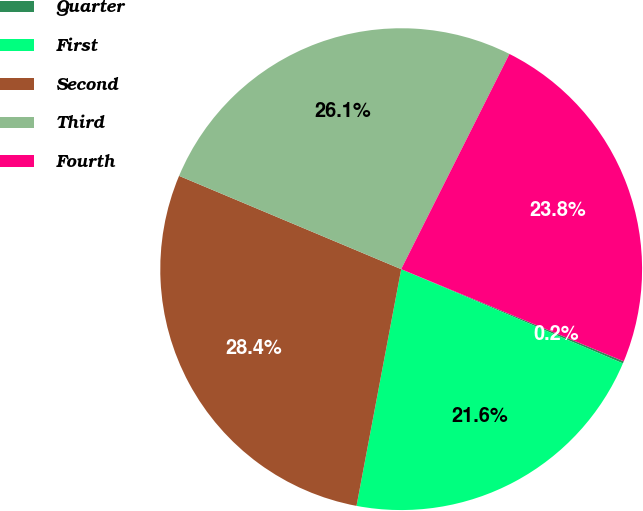Convert chart. <chart><loc_0><loc_0><loc_500><loc_500><pie_chart><fcel>Quarter<fcel>First<fcel>Second<fcel>Third<fcel>Fourth<nl><fcel>0.15%<fcel>21.57%<fcel>28.36%<fcel>26.09%<fcel>23.83%<nl></chart> 